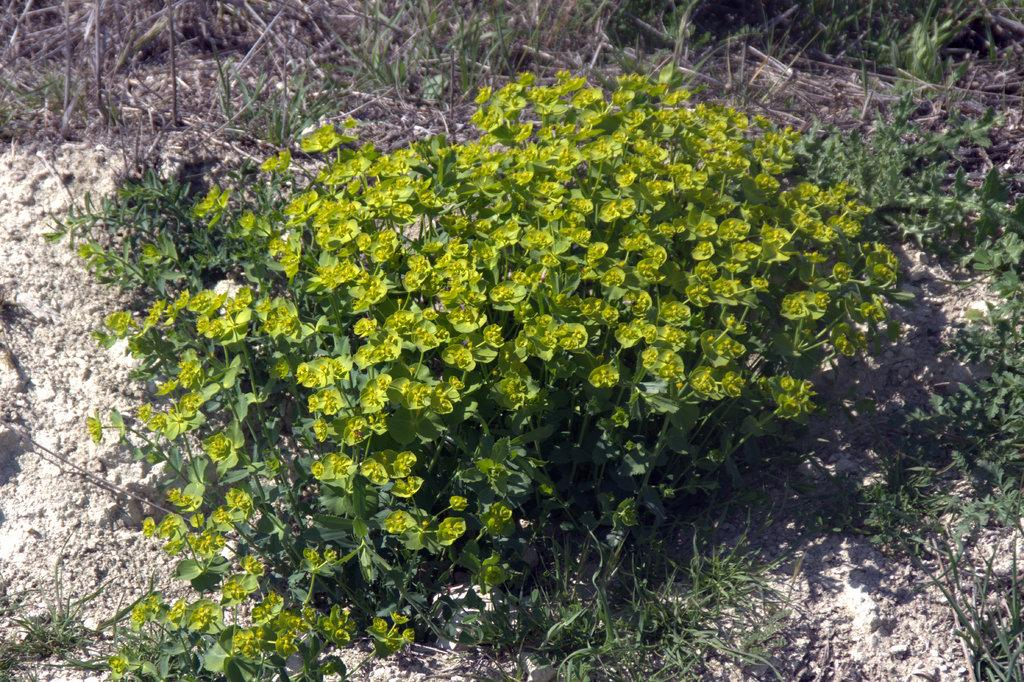What type of living organisms can be seen in the image? Plants can be seen in the image. What type of vegetation is visible in the image? There is grass visible in the image. What type of terrain is visible in the image? There is mud visible in the image. Where is the nest located in the image? There is no nest present in the image. What type of building is visible in the image? There is no building present in the image. What type of footwear is visible in the image? There is no footwear present in the image. 